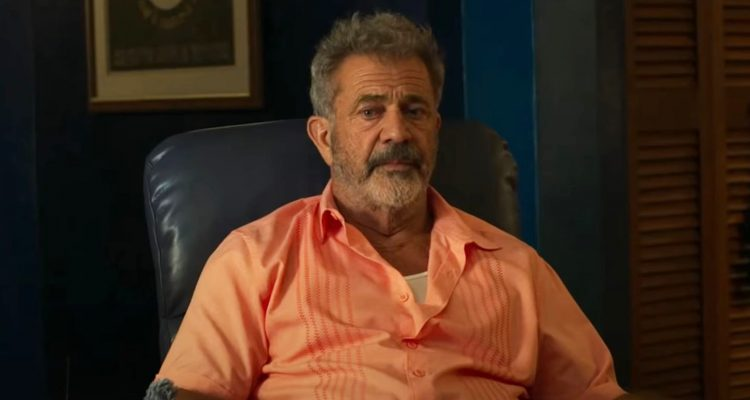Analyze the image in a comprehensive and detailed manner. In this image, an older man, who might be an actor or a character he is portraying, is seated in a blue leather chair, resembling an office setting. The man is wearing a light salmon-colored button-down shirt and has a gray beard. His serious expression indicates deep thought or contemplation. The background consists of a blue wall with a framed certificate and a wooden bookshelf, reinforcing the office-like atmosphere. Additionally, there is a louvered wooden door which adds a touch of casualness to the otherwise professional setting. 